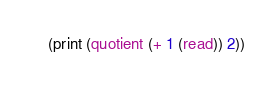<code> <loc_0><loc_0><loc_500><loc_500><_Scheme_>(print (quotient (+ 1 (read)) 2))</code> 